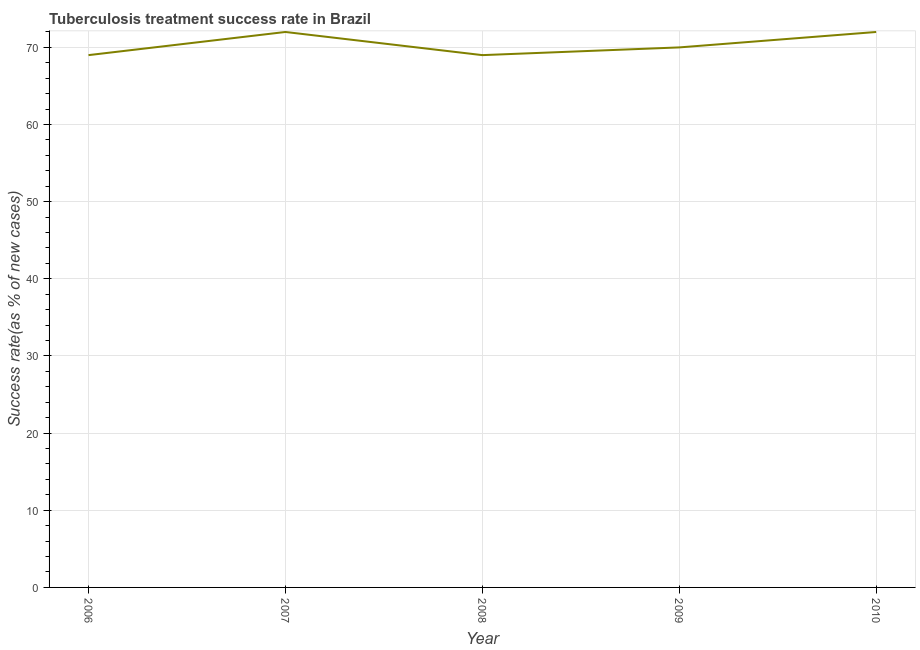What is the tuberculosis treatment success rate in 2006?
Your response must be concise. 69. Across all years, what is the maximum tuberculosis treatment success rate?
Provide a succinct answer. 72. Across all years, what is the minimum tuberculosis treatment success rate?
Your response must be concise. 69. In which year was the tuberculosis treatment success rate maximum?
Keep it short and to the point. 2007. What is the sum of the tuberculosis treatment success rate?
Ensure brevity in your answer.  352. What is the difference between the tuberculosis treatment success rate in 2008 and 2009?
Ensure brevity in your answer.  -1. What is the average tuberculosis treatment success rate per year?
Ensure brevity in your answer.  70.4. In how many years, is the tuberculosis treatment success rate greater than 24 %?
Make the answer very short. 5. What is the ratio of the tuberculosis treatment success rate in 2006 to that in 2009?
Keep it short and to the point. 0.99. Is the difference between the tuberculosis treatment success rate in 2007 and 2008 greater than the difference between any two years?
Ensure brevity in your answer.  Yes. Is the sum of the tuberculosis treatment success rate in 2006 and 2008 greater than the maximum tuberculosis treatment success rate across all years?
Provide a short and direct response. Yes. What is the difference between the highest and the lowest tuberculosis treatment success rate?
Make the answer very short. 3. How many lines are there?
Offer a terse response. 1. Are the values on the major ticks of Y-axis written in scientific E-notation?
Keep it short and to the point. No. Does the graph contain grids?
Make the answer very short. Yes. What is the title of the graph?
Offer a very short reply. Tuberculosis treatment success rate in Brazil. What is the label or title of the X-axis?
Give a very brief answer. Year. What is the label or title of the Y-axis?
Provide a succinct answer. Success rate(as % of new cases). What is the Success rate(as % of new cases) in 2010?
Your answer should be compact. 72. What is the difference between the Success rate(as % of new cases) in 2006 and 2007?
Ensure brevity in your answer.  -3. What is the difference between the Success rate(as % of new cases) in 2006 and 2009?
Provide a short and direct response. -1. What is the difference between the Success rate(as % of new cases) in 2007 and 2010?
Your response must be concise. 0. What is the ratio of the Success rate(as % of new cases) in 2006 to that in 2007?
Keep it short and to the point. 0.96. What is the ratio of the Success rate(as % of new cases) in 2006 to that in 2008?
Provide a succinct answer. 1. What is the ratio of the Success rate(as % of new cases) in 2006 to that in 2009?
Your answer should be very brief. 0.99. What is the ratio of the Success rate(as % of new cases) in 2006 to that in 2010?
Provide a succinct answer. 0.96. What is the ratio of the Success rate(as % of new cases) in 2007 to that in 2008?
Your answer should be very brief. 1.04. What is the ratio of the Success rate(as % of new cases) in 2007 to that in 2009?
Make the answer very short. 1.03. What is the ratio of the Success rate(as % of new cases) in 2007 to that in 2010?
Provide a short and direct response. 1. What is the ratio of the Success rate(as % of new cases) in 2008 to that in 2009?
Ensure brevity in your answer.  0.99. What is the ratio of the Success rate(as % of new cases) in 2008 to that in 2010?
Your response must be concise. 0.96. 